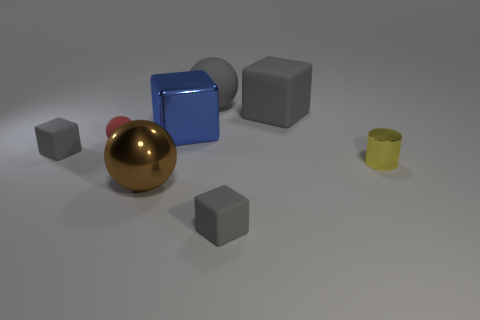There is a red object that is the same size as the yellow thing; what shape is it?
Keep it short and to the point. Sphere. How many matte cubes are the same color as the tiny rubber sphere?
Your answer should be compact. 0. Is the material of the large cube that is left of the big gray rubber cube the same as the tiny cylinder?
Offer a very short reply. Yes. What is the shape of the brown thing?
Offer a very short reply. Sphere. How many yellow things are rubber blocks or big metallic spheres?
Your answer should be compact. 0. How many other objects are there of the same material as the large blue thing?
Provide a short and direct response. 2. There is a tiny gray object that is right of the large blue cube; does it have the same shape as the yellow thing?
Offer a terse response. No. Are any metal cylinders visible?
Your answer should be compact. Yes. Is there anything else that has the same shape as the yellow object?
Provide a short and direct response. No. Are there more red balls that are behind the blue metallic block than large cyan matte cubes?
Your response must be concise. No. 